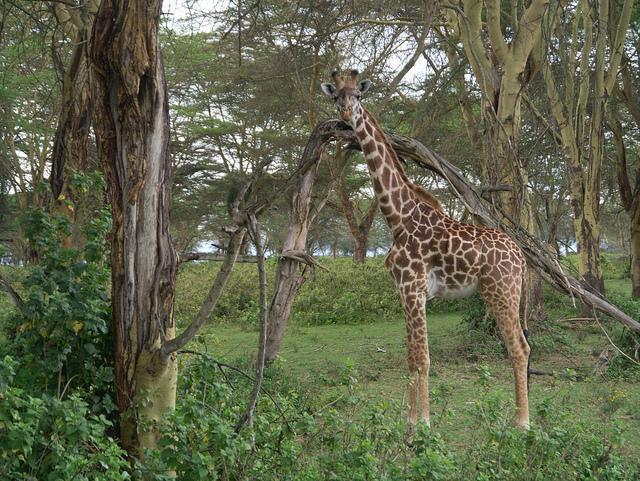How many animals are in this photo?
Give a very brief answer. 1. How many giraffes are there?
Give a very brief answer. 1. 